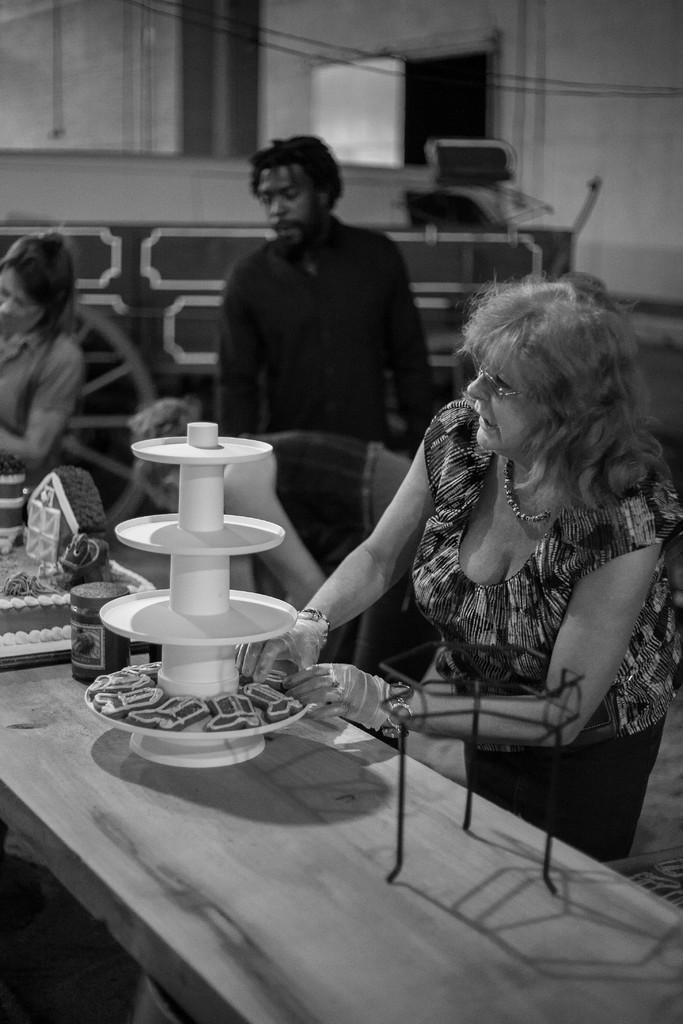Could you give a brief overview of what you see in this image? A black and white picture. This persons are standing. In-front of this person there is a table, on a table there is a cake, jar and cookies. 